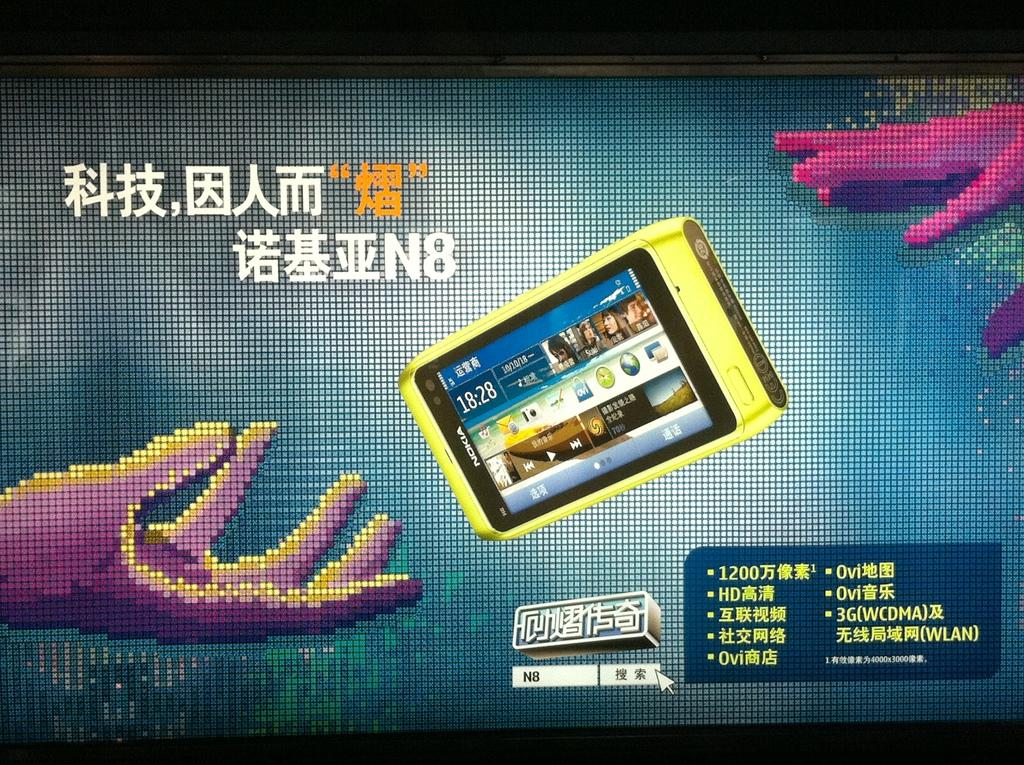<image>
Describe the image concisely. An advertisement with a Nokia phone shows the time is 18;28. 